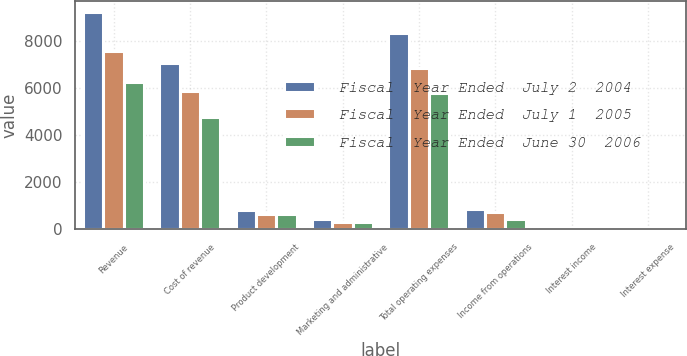<chart> <loc_0><loc_0><loc_500><loc_500><stacked_bar_chart><ecel><fcel>Revenue<fcel>Cost of revenue<fcel>Product development<fcel>Marketing and administrative<fcel>Total operating expenses<fcel>Income from operations<fcel>Interest income<fcel>Interest expense<nl><fcel>Fiscal  Year Ended  July 2  2004<fcel>9206<fcel>7069<fcel>805<fcel>447<fcel>8332<fcel>874<fcel>69<fcel>41<nl><fcel>Fiscal  Year Ended  July 1  2005<fcel>7553<fcel>5880<fcel>645<fcel>306<fcel>6831<fcel>722<fcel>36<fcel>48<nl><fcel>Fiscal  Year Ended  June 30  2006<fcel>6224<fcel>4765<fcel>666<fcel>290<fcel>5780<fcel>444<fcel>17<fcel>45<nl></chart> 